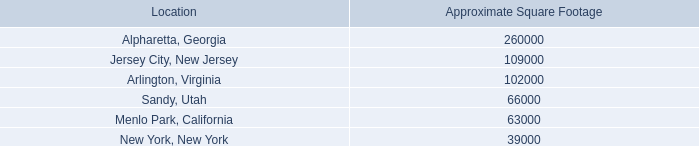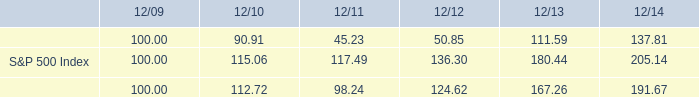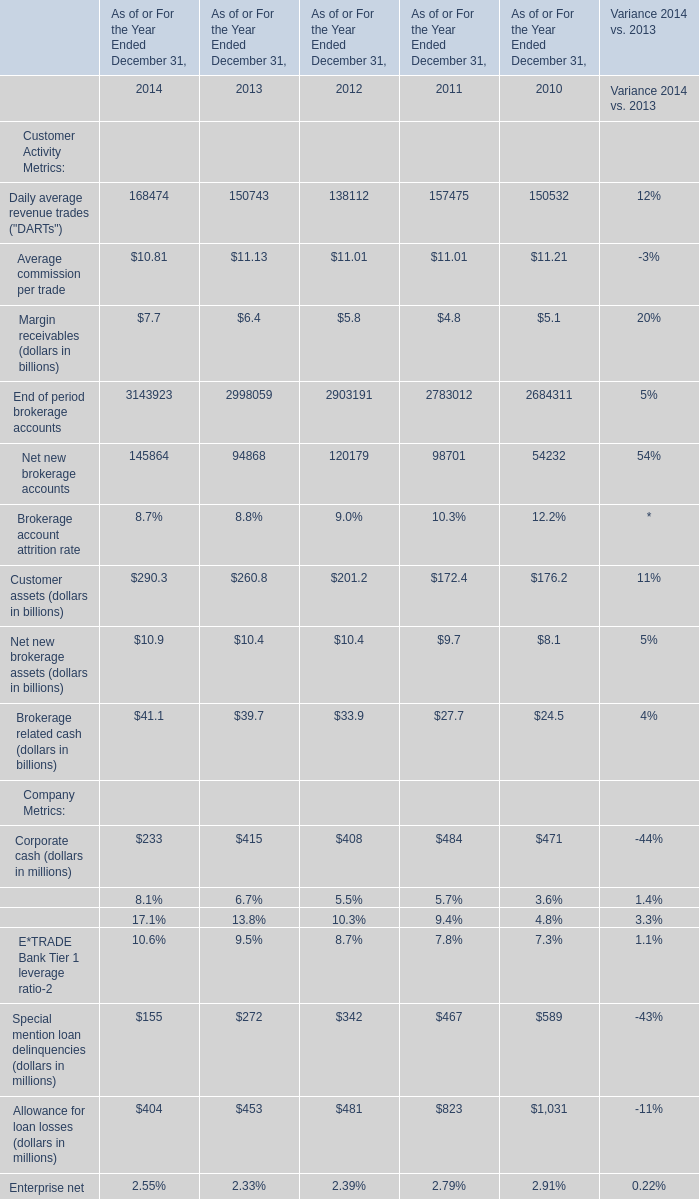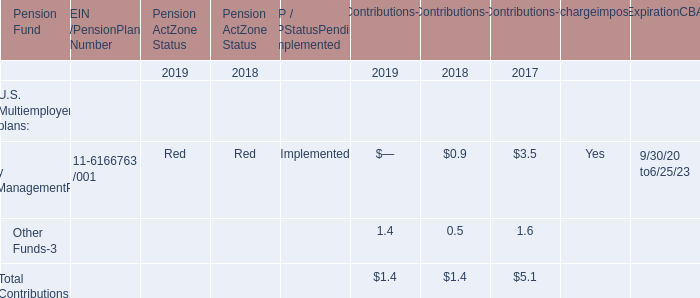what was the percent of the return on the e*trade financial corporation common stock from 2009 to 2014 
Computations: ((137.81 - 100) / 100)
Answer: 0.3781. 